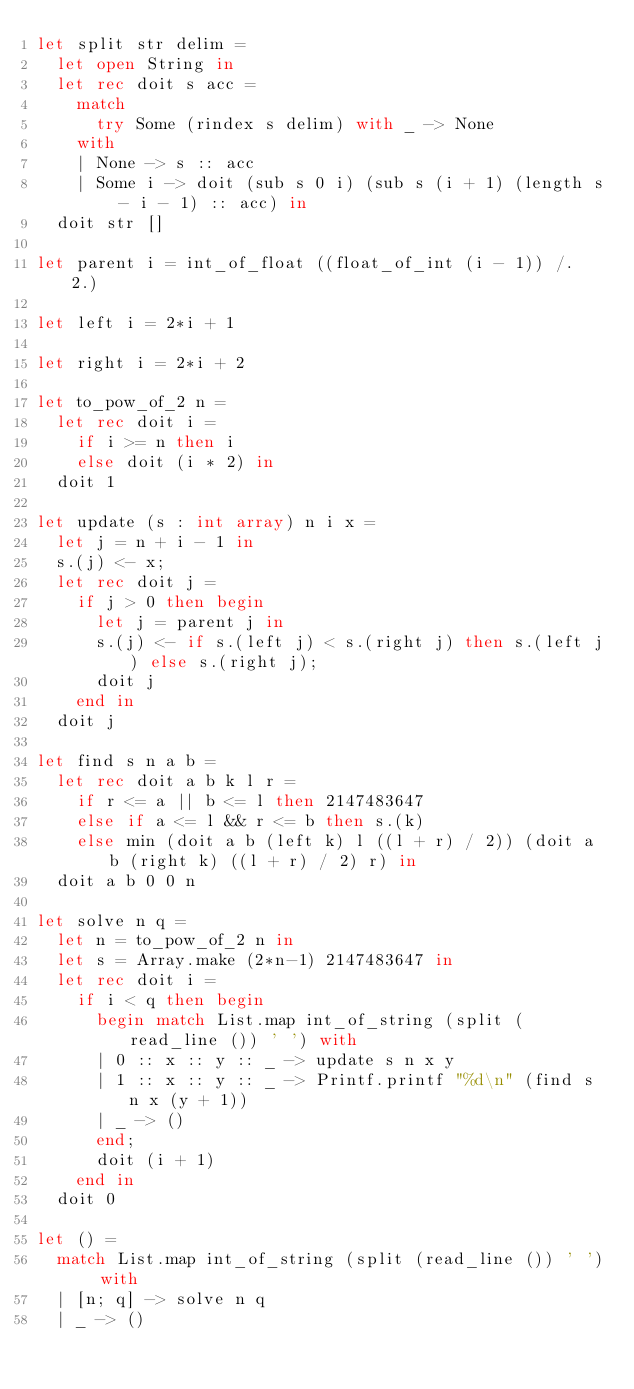<code> <loc_0><loc_0><loc_500><loc_500><_OCaml_>let split str delim =
  let open String in
  let rec doit s acc =
    match
      try Some (rindex s delim) with _ -> None
    with
    | None -> s :: acc
    | Some i -> doit (sub s 0 i) (sub s (i + 1) (length s - i - 1) :: acc) in
  doit str []

let parent i = int_of_float ((float_of_int (i - 1)) /. 2.)

let left i = 2*i + 1

let right i = 2*i + 2

let to_pow_of_2 n =
  let rec doit i =
    if i >= n then i
    else doit (i * 2) in
  doit 1

let update (s : int array) n i x =
  let j = n + i - 1 in
  s.(j) <- x;
  let rec doit j =
    if j > 0 then begin
      let j = parent j in
      s.(j) <- if s.(left j) < s.(right j) then s.(left j) else s.(right j);
      doit j
    end in
  doit j

let find s n a b =
  let rec doit a b k l r =
    if r <= a || b <= l then 2147483647
    else if a <= l && r <= b then s.(k)
    else min (doit a b (left k) l ((l + r) / 2)) (doit a b (right k) ((l + r) / 2) r) in
  doit a b 0 0 n

let solve n q =
  let n = to_pow_of_2 n in
  let s = Array.make (2*n-1) 2147483647 in
  let rec doit i =
    if i < q then begin
      begin match List.map int_of_string (split (read_line ()) ' ') with
      | 0 :: x :: y :: _ -> update s n x y
      | 1 :: x :: y :: _ -> Printf.printf "%d\n" (find s n x (y + 1))
      | _ -> ()
      end;
      doit (i + 1)
    end in
  doit 0

let () =
  match List.map int_of_string (split (read_line ()) ' ') with
  | [n; q] -> solve n q
  | _ -> ()</code> 